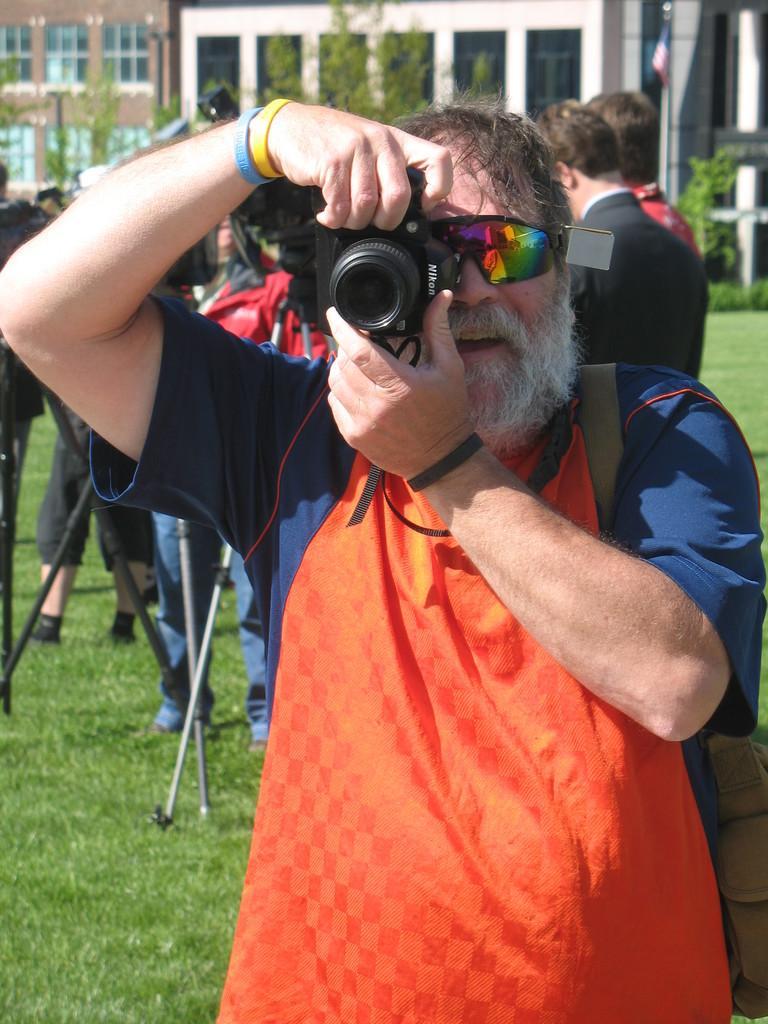Could you give a brief overview of what you see in this image? in the picture there is a person standing and holding a camera there are many persons behind. 